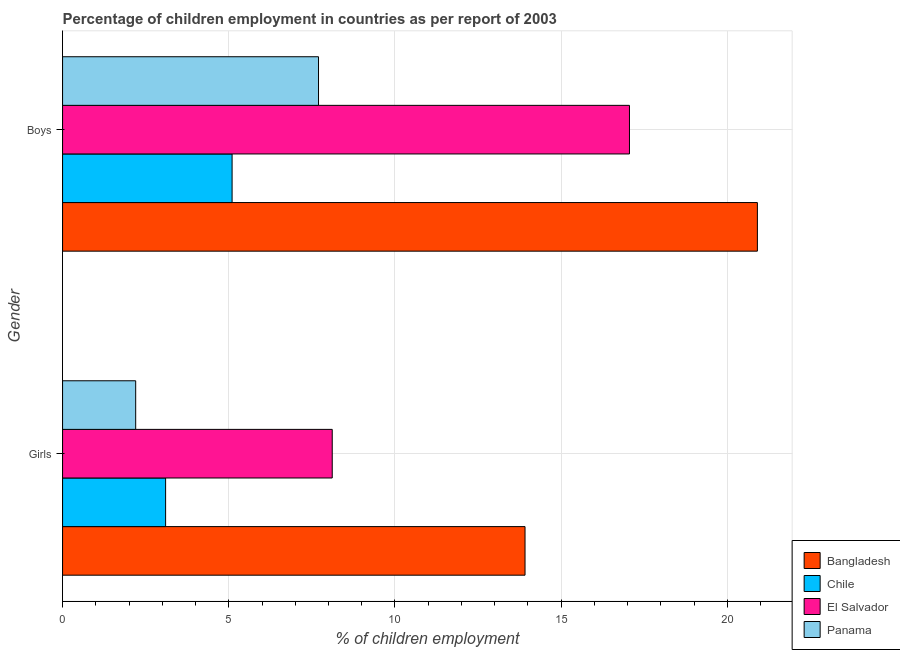How many different coloured bars are there?
Your answer should be very brief. 4. What is the label of the 1st group of bars from the top?
Offer a terse response. Boys. What is the percentage of employed girls in El Salvador?
Ensure brevity in your answer.  8.11. Across all countries, what is the maximum percentage of employed girls?
Make the answer very short. 13.91. In which country was the percentage of employed girls maximum?
Offer a terse response. Bangladesh. In which country was the percentage of employed girls minimum?
Your response must be concise. Panama. What is the total percentage of employed boys in the graph?
Offer a terse response. 50.76. What is the difference between the percentage of employed girls in Bangladesh and that in Chile?
Your answer should be compact. 10.81. What is the difference between the percentage of employed boys in Panama and the percentage of employed girls in Chile?
Your answer should be very brief. 4.6. What is the average percentage of employed boys per country?
Keep it short and to the point. 12.69. In how many countries, is the percentage of employed boys greater than 4 %?
Give a very brief answer. 4. What is the ratio of the percentage of employed girls in Panama to that in Chile?
Provide a succinct answer. 0.71. In how many countries, is the percentage of employed girls greater than the average percentage of employed girls taken over all countries?
Keep it short and to the point. 2. What does the 1st bar from the top in Boys represents?
Offer a very short reply. Panama. What does the 3rd bar from the bottom in Boys represents?
Your answer should be compact. El Salvador. Are all the bars in the graph horizontal?
Ensure brevity in your answer.  Yes. How many countries are there in the graph?
Offer a terse response. 4. Are the values on the major ticks of X-axis written in scientific E-notation?
Make the answer very short. No. Does the graph contain any zero values?
Make the answer very short. No. Where does the legend appear in the graph?
Ensure brevity in your answer.  Bottom right. How many legend labels are there?
Offer a terse response. 4. How are the legend labels stacked?
Provide a succinct answer. Vertical. What is the title of the graph?
Make the answer very short. Percentage of children employment in countries as per report of 2003. Does "High income: OECD" appear as one of the legend labels in the graph?
Ensure brevity in your answer.  No. What is the label or title of the X-axis?
Your response must be concise. % of children employment. What is the label or title of the Y-axis?
Your response must be concise. Gender. What is the % of children employment in Bangladesh in Girls?
Your response must be concise. 13.91. What is the % of children employment of Chile in Girls?
Your answer should be very brief. 3.1. What is the % of children employment in El Salvador in Girls?
Provide a short and direct response. 8.11. What is the % of children employment of Bangladesh in Boys?
Keep it short and to the point. 20.9. What is the % of children employment of Chile in Boys?
Provide a succinct answer. 5.1. What is the % of children employment in El Salvador in Boys?
Provide a short and direct response. 17.06. What is the % of children employment of Panama in Boys?
Provide a succinct answer. 7.7. Across all Gender, what is the maximum % of children employment in Bangladesh?
Make the answer very short. 20.9. Across all Gender, what is the maximum % of children employment of Chile?
Give a very brief answer. 5.1. Across all Gender, what is the maximum % of children employment of El Salvador?
Provide a short and direct response. 17.06. Across all Gender, what is the minimum % of children employment in Bangladesh?
Your answer should be compact. 13.91. Across all Gender, what is the minimum % of children employment in Chile?
Make the answer very short. 3.1. Across all Gender, what is the minimum % of children employment in El Salvador?
Your response must be concise. 8.11. Across all Gender, what is the minimum % of children employment of Panama?
Offer a very short reply. 2.2. What is the total % of children employment of Bangladesh in the graph?
Make the answer very short. 34.82. What is the total % of children employment in Chile in the graph?
Provide a succinct answer. 8.2. What is the total % of children employment in El Salvador in the graph?
Offer a very short reply. 25.17. What is the total % of children employment of Panama in the graph?
Offer a terse response. 9.9. What is the difference between the % of children employment in Bangladesh in Girls and that in Boys?
Your answer should be compact. -6.99. What is the difference between the % of children employment in Chile in Girls and that in Boys?
Provide a succinct answer. -2. What is the difference between the % of children employment of El Salvador in Girls and that in Boys?
Make the answer very short. -8.94. What is the difference between the % of children employment in Bangladesh in Girls and the % of children employment in Chile in Boys?
Give a very brief answer. 8.81. What is the difference between the % of children employment in Bangladesh in Girls and the % of children employment in El Salvador in Boys?
Ensure brevity in your answer.  -3.14. What is the difference between the % of children employment in Bangladesh in Girls and the % of children employment in Panama in Boys?
Ensure brevity in your answer.  6.21. What is the difference between the % of children employment in Chile in Girls and the % of children employment in El Salvador in Boys?
Ensure brevity in your answer.  -13.96. What is the difference between the % of children employment in El Salvador in Girls and the % of children employment in Panama in Boys?
Offer a very short reply. 0.41. What is the average % of children employment of Bangladesh per Gender?
Offer a very short reply. 17.41. What is the average % of children employment in Chile per Gender?
Offer a terse response. 4.1. What is the average % of children employment of El Salvador per Gender?
Your answer should be very brief. 12.58. What is the average % of children employment in Panama per Gender?
Ensure brevity in your answer.  4.95. What is the difference between the % of children employment in Bangladesh and % of children employment in Chile in Girls?
Keep it short and to the point. 10.81. What is the difference between the % of children employment of Bangladesh and % of children employment of El Salvador in Girls?
Keep it short and to the point. 5.8. What is the difference between the % of children employment in Bangladesh and % of children employment in Panama in Girls?
Offer a terse response. 11.71. What is the difference between the % of children employment in Chile and % of children employment in El Salvador in Girls?
Provide a succinct answer. -5.01. What is the difference between the % of children employment of Chile and % of children employment of Panama in Girls?
Offer a terse response. 0.9. What is the difference between the % of children employment in El Salvador and % of children employment in Panama in Girls?
Provide a succinct answer. 5.91. What is the difference between the % of children employment in Bangladesh and % of children employment in Chile in Boys?
Provide a succinct answer. 15.8. What is the difference between the % of children employment of Bangladesh and % of children employment of El Salvador in Boys?
Offer a terse response. 3.85. What is the difference between the % of children employment of Bangladesh and % of children employment of Panama in Boys?
Provide a short and direct response. 13.2. What is the difference between the % of children employment in Chile and % of children employment in El Salvador in Boys?
Provide a short and direct response. -11.96. What is the difference between the % of children employment of El Salvador and % of children employment of Panama in Boys?
Make the answer very short. 9.36. What is the ratio of the % of children employment in Bangladesh in Girls to that in Boys?
Your answer should be compact. 0.67. What is the ratio of the % of children employment of Chile in Girls to that in Boys?
Your answer should be compact. 0.61. What is the ratio of the % of children employment of El Salvador in Girls to that in Boys?
Provide a short and direct response. 0.48. What is the ratio of the % of children employment in Panama in Girls to that in Boys?
Ensure brevity in your answer.  0.29. What is the difference between the highest and the second highest % of children employment of Bangladesh?
Your answer should be very brief. 6.99. What is the difference between the highest and the second highest % of children employment in Chile?
Offer a terse response. 2. What is the difference between the highest and the second highest % of children employment of El Salvador?
Your answer should be very brief. 8.94. What is the difference between the highest and the lowest % of children employment of Bangladesh?
Ensure brevity in your answer.  6.99. What is the difference between the highest and the lowest % of children employment of Chile?
Your answer should be compact. 2. What is the difference between the highest and the lowest % of children employment of El Salvador?
Provide a short and direct response. 8.94. What is the difference between the highest and the lowest % of children employment in Panama?
Offer a very short reply. 5.5. 